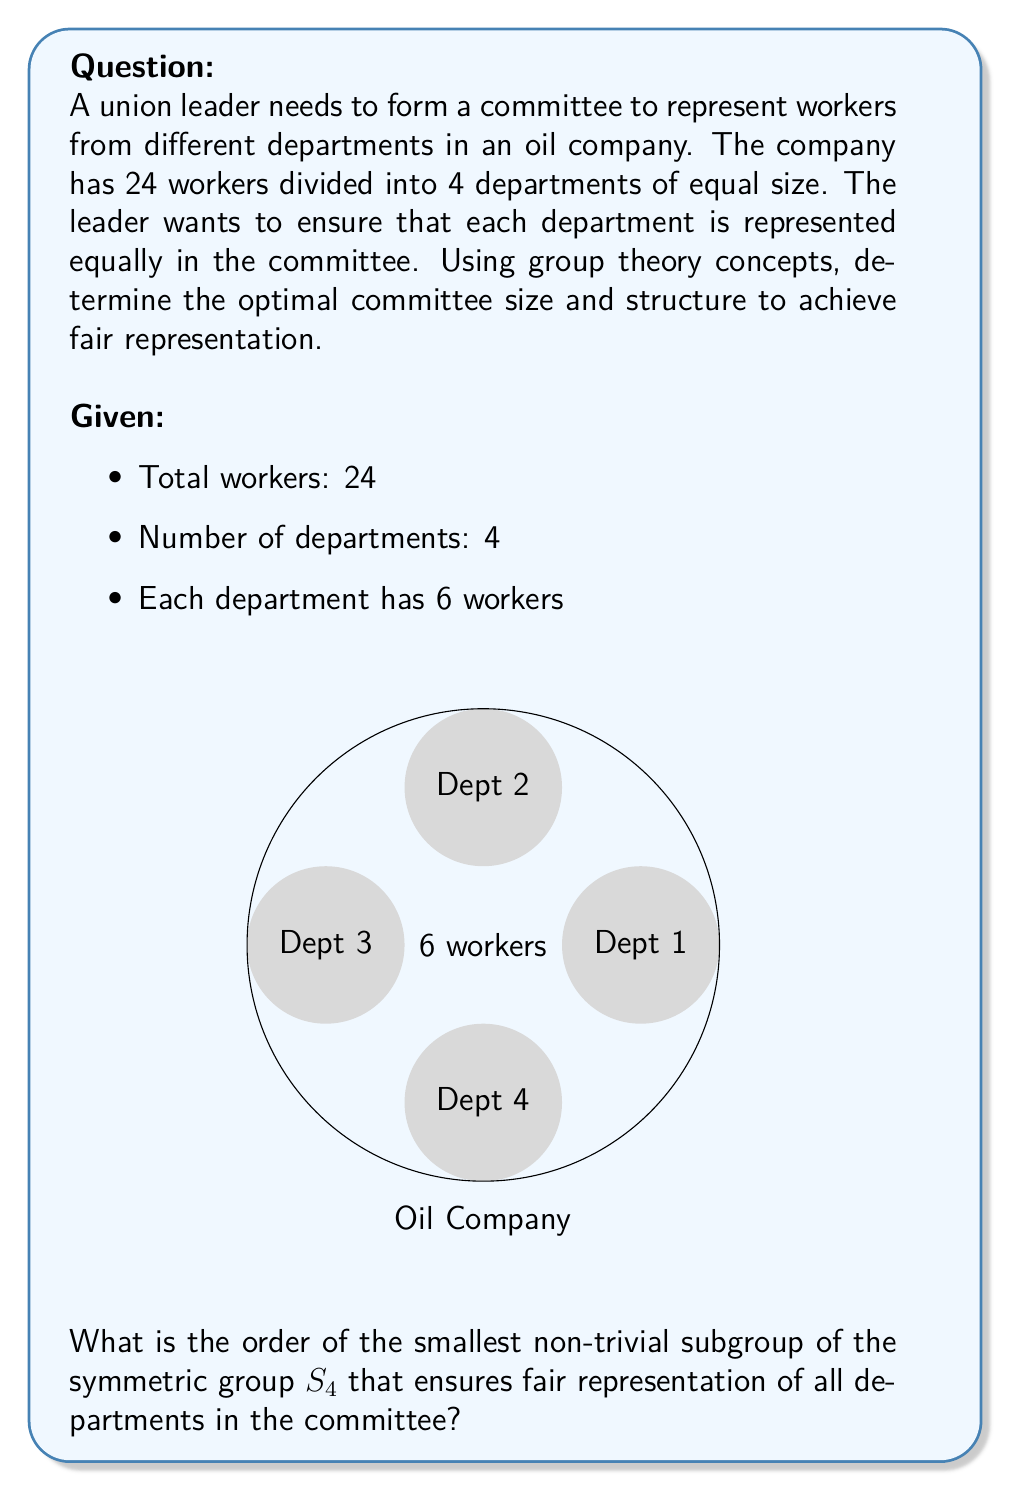Provide a solution to this math problem. Let's approach this step-by-step using group theory concepts:

1) The symmetric group $S_4$ represents all possible permutations of the 4 departments.

2) We need to find a subgroup of $S_4$ that ensures each department is represented equally.

3) The order of $S_4$ is $4! = 24$.

4) The possible orders of subgroups of $S_4$ are the divisors of 24: 1, 2, 3, 4, 6, 8, 12, and 24.

5) We need a subgroup that rotates through all 4 departments. The smallest such subgroup would be a cyclic group of order 4, $C_4$.

6) $C_4$ is isomorphic to the cyclic group generated by the 4-cycle $(1234)$ in $S_4$.

7) This 4-cycle ensures that each department takes turns being in each position, providing fair representation.

8) The elements of this subgroup are:
   $e$ (identity)
   $(1234)$
   $(13)(24)$
   $(1432)$

9) Each element of this subgroup represents a different committee composition, cycling through all departments.

10) The order of this subgroup is 4, which is the smallest non-trivial order that ensures fair representation.

Therefore, the optimal committee size is 4, with each member representing a different department, and the positions rotating according to the cyclic group $C_4$.
Answer: 4 